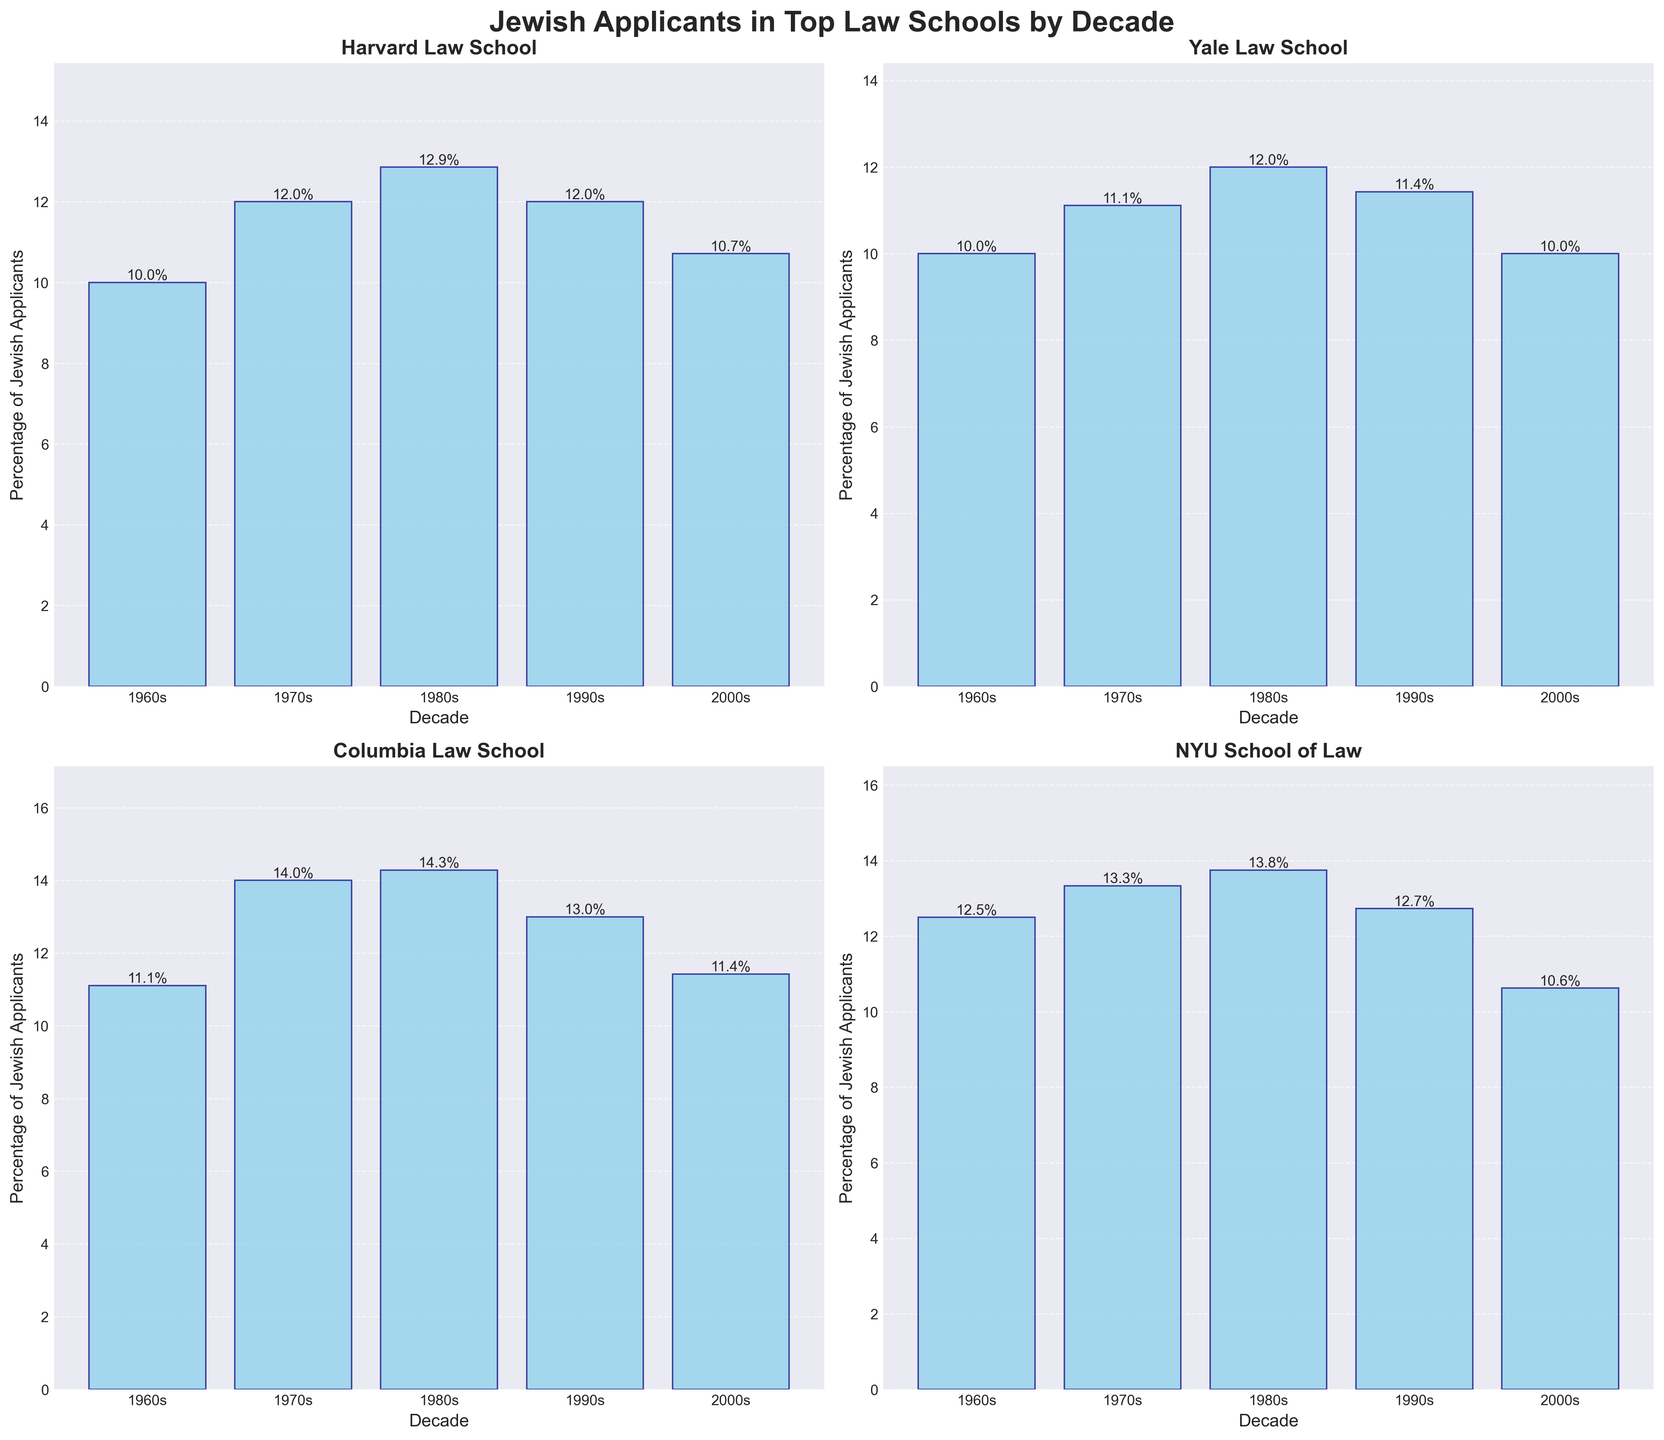Which law school had the highest percentage of Jewish applicants in the 1960s? First, identify the bars for the 1960s in each subplot. Then, compare the heights of these bars to see which one is the tallest. NYU School of Law stands out with the highest bar for the 1960s.
Answer: NYU School of Law What was the percentage of Jewish applicants at Harvard Law School in the 2000s? Look for the bar corresponding to the 2000s (the farthest right bar) in the Harvard Law School subplot. The text above the bar provides the exact percentage.
Answer: 10.7% Which decade saw the highest percentage increase in Jewish applicants for Yale Law School compared to the previous decade? Examine the heights of the bars for each decade in the Yale Law School subplot and calculate the percentage differences between successive decades. The most significant increase is from the 1970s to the 1980s.
Answer: 1970s to 1980s Compare the percentages of Jewish applicants in the 1980s for Columbia and NYU. Which school had a higher percentage? Look at the heights of the bars for the 1980s (second from the right) in both the Columbia and NYU subplots. The specific percentages are labeled, with NYU having the higher percentage.
Answer: NYU Which law school had the least variation in the percentage of Jewish applicants over the decades? Examine the heights of the bars for each law school across the four subplots. The school with bars that are the most similar in height has the least variation. Columbia Law School shows relatively consistent bar heights over the decades.
Answer: Columbia Law School How did the percentage of Jewish applicants at NYU in the 1990s compare to that in the 2000s? Look at the bar heights for the 1990s and 2000s in the NYU subplot and compare them. The text labels show a smaller percentage in the 1990s than in the 2000s.
Answer: Increased Can you find a decade where all four law schools had an increase in the percentage of Jewish applicants compared to the previous decade? Check each subplot and compare the bar heights from one decade to the next. In the 1980s, all four schools had an increase in percentage compared to the 1970s.
Answer: 1980s Calculate the average percentage of Jewish applicants for Yale Law School over all decades. Add the percentages for each decade from Yale Law School subplot and divide by the number of decades (5). (10%, 11.1%, 12%, 11.4%, 10%) Average = (10 + 11.1 + 12 + 11.4 + 10) / 5 = 10.9%.
Answer: 10.9% Was there any school where the percentage of Jewish applicants decreased every decade? Observe the bar heights for each school across the decades. None of the schools show a consistent decrease every decade.
Answer: No 